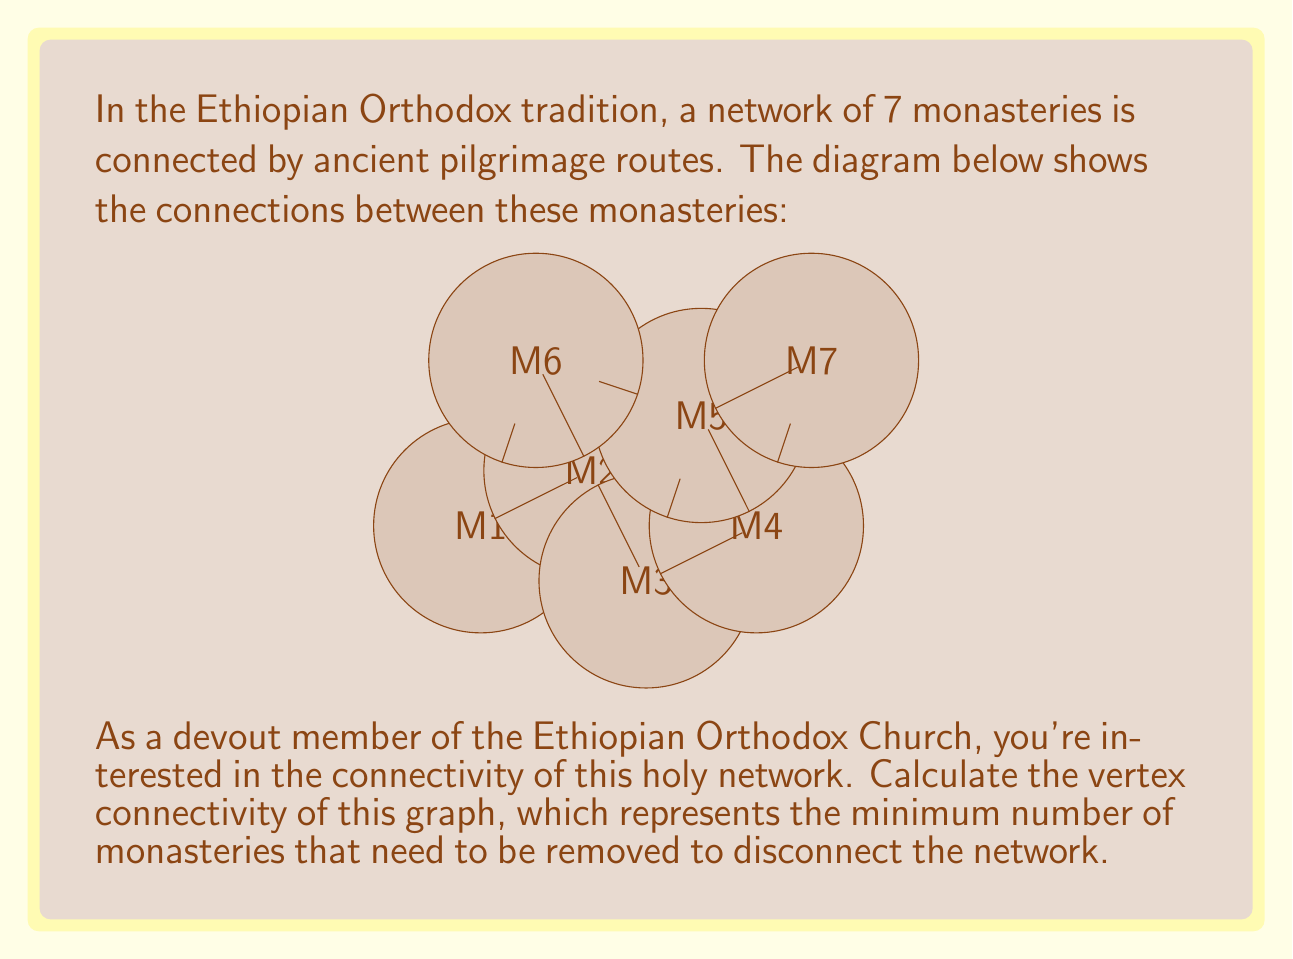Show me your answer to this math problem. To find the vertex connectivity of this graph, we need to determine the minimum number of vertices (monasteries) that, when removed, would disconnect the graph or reduce it to a single vertex. Let's approach this step-by-step:

1) First, observe that the graph is not complete (not all vertices are directly connected to each other), so the vertex connectivity will be less than 6 (n-1 where n is the number of vertices).

2) We can see that removing any single vertex does not disconnect the graph, so the vertex connectivity is at least 2.

3) Let's try removing two vertices:
   - Removing M1 and M5 disconnects M6 from the rest of the graph.
   - Removing M3 and M4 also disconnects the graph into two components.

4) Since we found a way to disconnect the graph by removing two vertices, and we previously established that removing one vertex is not sufficient, the vertex connectivity of this graph is 2.

5) To verify, we can check that there are at least two vertex-disjoint paths between any pair of vertices in the graph, which confirms that the vertex connectivity is indeed 2.

In the context of the monasteries, this means that at least two monasteries would need to be closed or isolated to break the pilgrimage network into disconnected components.
Answer: 2 